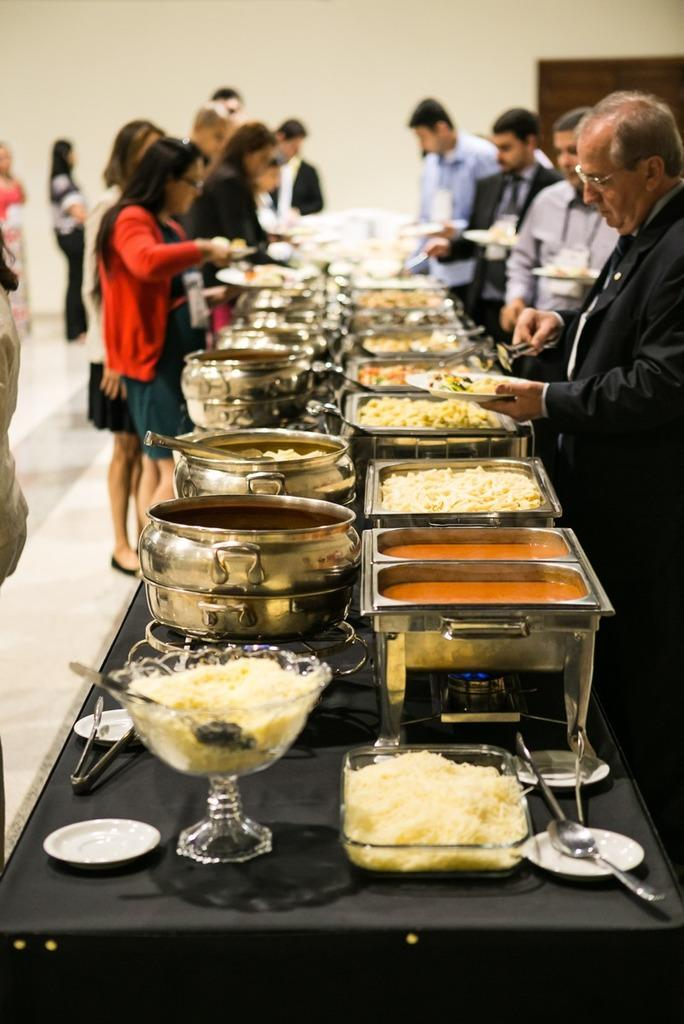What is located in the middle of the image? There is a table in the middle of the image. What is on the table? There are dishes and spoons on the table. Who is present in the image? There are people standing in the middle of the image. What can be seen in the background of the image? There is a wall in the background of the image. What type of teaching is happening in the image? There is no teaching happening in the image; it features a table with dishes and spoons, people standing, and a wall in the background. Can you see any blood or brain in the image? No, there is no blood or brain present in the image. 